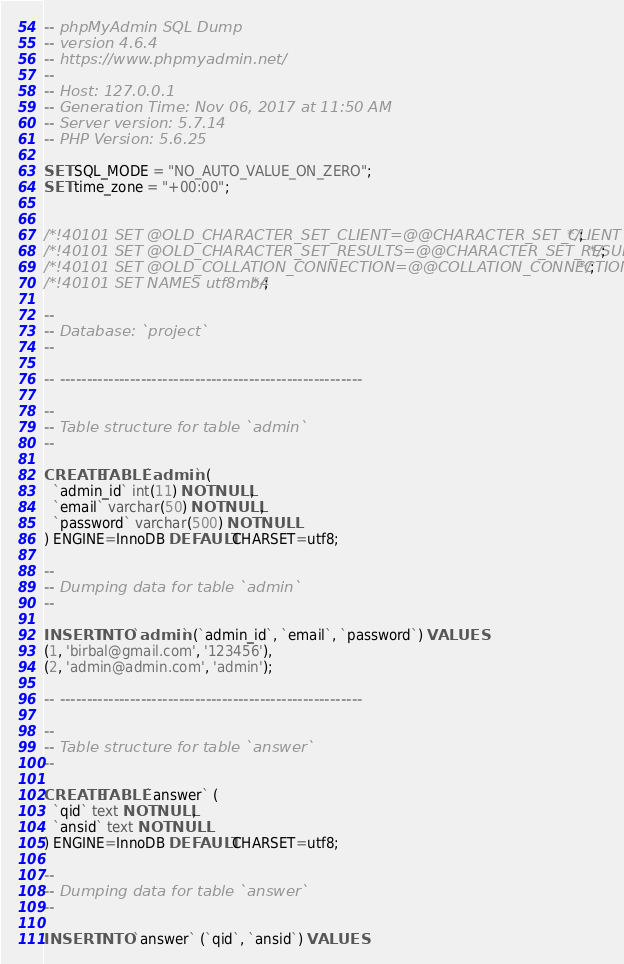Convert code to text. <code><loc_0><loc_0><loc_500><loc_500><_SQL_>-- phpMyAdmin SQL Dump
-- version 4.6.4
-- https://www.phpmyadmin.net/
--
-- Host: 127.0.0.1
-- Generation Time: Nov 06, 2017 at 11:50 AM
-- Server version: 5.7.14
-- PHP Version: 5.6.25

SET SQL_MODE = "NO_AUTO_VALUE_ON_ZERO";
SET time_zone = "+00:00";


/*!40101 SET @OLD_CHARACTER_SET_CLIENT=@@CHARACTER_SET_CLIENT */;
/*!40101 SET @OLD_CHARACTER_SET_RESULTS=@@CHARACTER_SET_RESULTS */;
/*!40101 SET @OLD_COLLATION_CONNECTION=@@COLLATION_CONNECTION */;
/*!40101 SET NAMES utf8mb4 */;

--
-- Database: `project`
--

-- --------------------------------------------------------

--
-- Table structure for table `admin`
--

CREATE TABLE `admin` (
  `admin_id` int(11) NOT NULL,
  `email` varchar(50) NOT NULL,
  `password` varchar(500) NOT NULL
) ENGINE=InnoDB DEFAULT CHARSET=utf8;

--
-- Dumping data for table `admin`
--

INSERT INTO `admin` (`admin_id`, `email`, `password`) VALUES
(1, 'birbal@gmail.com', '123456'),
(2, 'admin@admin.com', 'admin');

-- --------------------------------------------------------

--
-- Table structure for table `answer`
--

CREATE TABLE `answer` (
  `qid` text NOT NULL,
  `ansid` text NOT NULL
) ENGINE=InnoDB DEFAULT CHARSET=utf8;

--
-- Dumping data for table `answer`
--

INSERT INTO `answer` (`qid`, `ansid`) VALUES</code> 